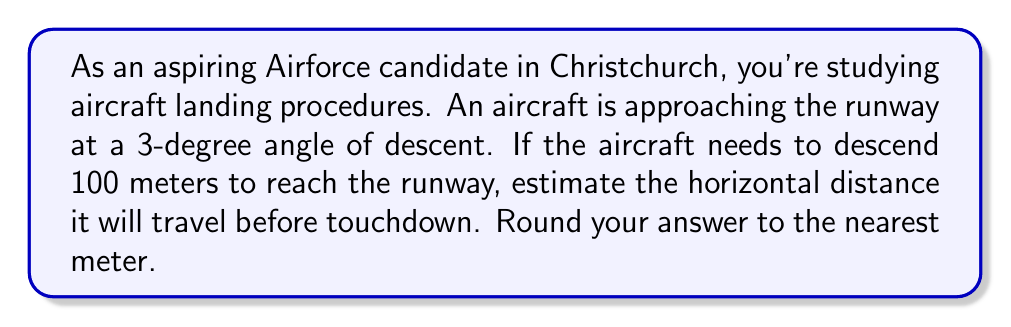Can you solve this math problem? Let's approach this problem step-by-step using trigonometry:

1) First, let's visualize the problem:

[asy]
import geometry;

size(200);
pair A = (0,0);
pair B = (1900,100);
pair C = (1900,0);

draw(A--B--C--cycle);

label("Runway", (950,-10), S);
label("100m", (1910,50), E);
label("3°", (50,10), NW);
label("x", (950,0), S);

draw(rightangle(A,C,B,25));
[/asy]

2) We can see that this forms a right-angled triangle. We know:
   - The vertical distance (opposite side) is 100 meters
   - The angle of descent is 3 degrees

3) We need to find the horizontal distance (adjacent side). This is a perfect scenario for using the tangent function.

4) The tangent of an angle in a right-angled triangle is the ratio of the opposite side to the adjacent side:

   $$\tan(\theta) = \frac{\text{opposite}}{\text{adjacent}}$$

5) In our case:
   $$\tan(3°) = \frac{100}{\text{horizontal distance}}$$

6) Let's call the horizontal distance $x$. We can rearrange the equation:
   $$x = \frac{100}{\tan(3°)}$$

7) Now let's calculate:
   $$x = \frac{100}{\tan(3°)} \approx 1908.56 \text{ meters}$$

8) Rounding to the nearest meter:
   $$x \approx 1909 \text{ meters}$$
Answer: 1909 meters 